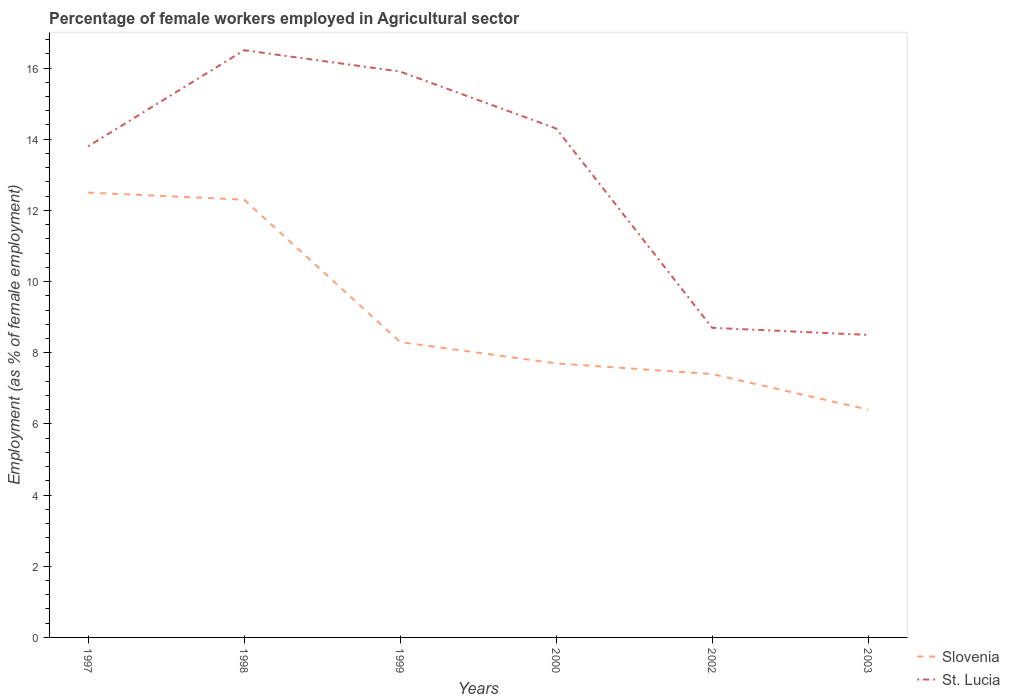How many different coloured lines are there?
Offer a very short reply. 2. Is the number of lines equal to the number of legend labels?
Give a very brief answer. Yes. Across all years, what is the maximum percentage of females employed in Agricultural sector in Slovenia?
Make the answer very short. 6.4. What is the total percentage of females employed in Agricultural sector in St. Lucia in the graph?
Your answer should be very brief. 5.8. What is the difference between the highest and the second highest percentage of females employed in Agricultural sector in Slovenia?
Give a very brief answer. 6.1. What is the difference between the highest and the lowest percentage of females employed in Agricultural sector in St. Lucia?
Make the answer very short. 4. How many lines are there?
Offer a very short reply. 2. What is the difference between two consecutive major ticks on the Y-axis?
Give a very brief answer. 2. Are the values on the major ticks of Y-axis written in scientific E-notation?
Keep it short and to the point. No. How many legend labels are there?
Keep it short and to the point. 2. What is the title of the graph?
Your answer should be compact. Percentage of female workers employed in Agricultural sector. What is the label or title of the Y-axis?
Offer a very short reply. Employment (as % of female employment). What is the Employment (as % of female employment) of St. Lucia in 1997?
Provide a succinct answer. 13.8. What is the Employment (as % of female employment) of Slovenia in 1998?
Offer a very short reply. 12.3. What is the Employment (as % of female employment) of Slovenia in 1999?
Offer a very short reply. 8.3. What is the Employment (as % of female employment) of St. Lucia in 1999?
Your response must be concise. 15.9. What is the Employment (as % of female employment) of Slovenia in 2000?
Your response must be concise. 7.7. What is the Employment (as % of female employment) in St. Lucia in 2000?
Your answer should be compact. 14.3. What is the Employment (as % of female employment) of Slovenia in 2002?
Offer a very short reply. 7.4. What is the Employment (as % of female employment) in St. Lucia in 2002?
Keep it short and to the point. 8.7. What is the Employment (as % of female employment) of Slovenia in 2003?
Your answer should be compact. 6.4. Across all years, what is the maximum Employment (as % of female employment) of Slovenia?
Your response must be concise. 12.5. Across all years, what is the maximum Employment (as % of female employment) in St. Lucia?
Offer a terse response. 16.5. Across all years, what is the minimum Employment (as % of female employment) of Slovenia?
Provide a succinct answer. 6.4. Across all years, what is the minimum Employment (as % of female employment) in St. Lucia?
Provide a short and direct response. 8.5. What is the total Employment (as % of female employment) in Slovenia in the graph?
Your answer should be very brief. 54.6. What is the total Employment (as % of female employment) of St. Lucia in the graph?
Offer a very short reply. 77.7. What is the difference between the Employment (as % of female employment) in Slovenia in 1997 and that in 1998?
Ensure brevity in your answer.  0.2. What is the difference between the Employment (as % of female employment) in St. Lucia in 1997 and that in 1999?
Your response must be concise. -2.1. What is the difference between the Employment (as % of female employment) of Slovenia in 1997 and that in 2000?
Make the answer very short. 4.8. What is the difference between the Employment (as % of female employment) in St. Lucia in 1997 and that in 2000?
Provide a succinct answer. -0.5. What is the difference between the Employment (as % of female employment) of Slovenia in 1997 and that in 2002?
Offer a very short reply. 5.1. What is the difference between the Employment (as % of female employment) in St. Lucia in 1997 and that in 2002?
Provide a succinct answer. 5.1. What is the difference between the Employment (as % of female employment) of St. Lucia in 1997 and that in 2003?
Your answer should be compact. 5.3. What is the difference between the Employment (as % of female employment) of Slovenia in 1998 and that in 2003?
Keep it short and to the point. 5.9. What is the difference between the Employment (as % of female employment) in Slovenia in 1999 and that in 2000?
Offer a very short reply. 0.6. What is the difference between the Employment (as % of female employment) in Slovenia in 1999 and that in 2002?
Provide a short and direct response. 0.9. What is the difference between the Employment (as % of female employment) in Slovenia in 2000 and that in 2002?
Offer a terse response. 0.3. What is the difference between the Employment (as % of female employment) in St. Lucia in 2000 and that in 2002?
Your answer should be very brief. 5.6. What is the difference between the Employment (as % of female employment) of Slovenia in 2000 and that in 2003?
Make the answer very short. 1.3. What is the difference between the Employment (as % of female employment) in St. Lucia in 2000 and that in 2003?
Offer a terse response. 5.8. What is the difference between the Employment (as % of female employment) in Slovenia in 1997 and the Employment (as % of female employment) in St. Lucia in 1998?
Give a very brief answer. -4. What is the difference between the Employment (as % of female employment) of Slovenia in 1997 and the Employment (as % of female employment) of St. Lucia in 1999?
Give a very brief answer. -3.4. What is the difference between the Employment (as % of female employment) in Slovenia in 1997 and the Employment (as % of female employment) in St. Lucia in 2000?
Offer a very short reply. -1.8. What is the difference between the Employment (as % of female employment) in Slovenia in 1997 and the Employment (as % of female employment) in St. Lucia in 2002?
Keep it short and to the point. 3.8. What is the difference between the Employment (as % of female employment) of Slovenia in 1998 and the Employment (as % of female employment) of St. Lucia in 2000?
Your response must be concise. -2. What is the difference between the Employment (as % of female employment) in Slovenia in 1998 and the Employment (as % of female employment) in St. Lucia in 2002?
Offer a terse response. 3.6. What is the difference between the Employment (as % of female employment) of Slovenia in 1998 and the Employment (as % of female employment) of St. Lucia in 2003?
Your answer should be very brief. 3.8. What is the difference between the Employment (as % of female employment) in Slovenia in 1999 and the Employment (as % of female employment) in St. Lucia in 2000?
Your response must be concise. -6. What is the difference between the Employment (as % of female employment) in Slovenia in 1999 and the Employment (as % of female employment) in St. Lucia in 2002?
Ensure brevity in your answer.  -0.4. What is the difference between the Employment (as % of female employment) in Slovenia in 2000 and the Employment (as % of female employment) in St. Lucia in 2003?
Provide a succinct answer. -0.8. What is the average Employment (as % of female employment) of Slovenia per year?
Offer a very short reply. 9.1. What is the average Employment (as % of female employment) of St. Lucia per year?
Your answer should be very brief. 12.95. In the year 1997, what is the difference between the Employment (as % of female employment) in Slovenia and Employment (as % of female employment) in St. Lucia?
Your answer should be compact. -1.3. In the year 1998, what is the difference between the Employment (as % of female employment) in Slovenia and Employment (as % of female employment) in St. Lucia?
Your answer should be compact. -4.2. In the year 2000, what is the difference between the Employment (as % of female employment) of Slovenia and Employment (as % of female employment) of St. Lucia?
Your answer should be compact. -6.6. In the year 2002, what is the difference between the Employment (as % of female employment) of Slovenia and Employment (as % of female employment) of St. Lucia?
Your answer should be compact. -1.3. What is the ratio of the Employment (as % of female employment) in Slovenia in 1997 to that in 1998?
Ensure brevity in your answer.  1.02. What is the ratio of the Employment (as % of female employment) of St. Lucia in 1997 to that in 1998?
Ensure brevity in your answer.  0.84. What is the ratio of the Employment (as % of female employment) of Slovenia in 1997 to that in 1999?
Your response must be concise. 1.51. What is the ratio of the Employment (as % of female employment) of St. Lucia in 1997 to that in 1999?
Make the answer very short. 0.87. What is the ratio of the Employment (as % of female employment) of Slovenia in 1997 to that in 2000?
Ensure brevity in your answer.  1.62. What is the ratio of the Employment (as % of female employment) in St. Lucia in 1997 to that in 2000?
Offer a terse response. 0.96. What is the ratio of the Employment (as % of female employment) in Slovenia in 1997 to that in 2002?
Your answer should be very brief. 1.69. What is the ratio of the Employment (as % of female employment) in St. Lucia in 1997 to that in 2002?
Ensure brevity in your answer.  1.59. What is the ratio of the Employment (as % of female employment) in Slovenia in 1997 to that in 2003?
Your answer should be compact. 1.95. What is the ratio of the Employment (as % of female employment) of St. Lucia in 1997 to that in 2003?
Ensure brevity in your answer.  1.62. What is the ratio of the Employment (as % of female employment) in Slovenia in 1998 to that in 1999?
Provide a succinct answer. 1.48. What is the ratio of the Employment (as % of female employment) of St. Lucia in 1998 to that in 1999?
Make the answer very short. 1.04. What is the ratio of the Employment (as % of female employment) in Slovenia in 1998 to that in 2000?
Give a very brief answer. 1.6. What is the ratio of the Employment (as % of female employment) of St. Lucia in 1998 to that in 2000?
Give a very brief answer. 1.15. What is the ratio of the Employment (as % of female employment) of Slovenia in 1998 to that in 2002?
Provide a short and direct response. 1.66. What is the ratio of the Employment (as % of female employment) of St. Lucia in 1998 to that in 2002?
Provide a succinct answer. 1.9. What is the ratio of the Employment (as % of female employment) in Slovenia in 1998 to that in 2003?
Give a very brief answer. 1.92. What is the ratio of the Employment (as % of female employment) in St. Lucia in 1998 to that in 2003?
Your answer should be compact. 1.94. What is the ratio of the Employment (as % of female employment) in Slovenia in 1999 to that in 2000?
Offer a very short reply. 1.08. What is the ratio of the Employment (as % of female employment) of St. Lucia in 1999 to that in 2000?
Your response must be concise. 1.11. What is the ratio of the Employment (as % of female employment) in Slovenia in 1999 to that in 2002?
Ensure brevity in your answer.  1.12. What is the ratio of the Employment (as % of female employment) in St. Lucia in 1999 to that in 2002?
Your response must be concise. 1.83. What is the ratio of the Employment (as % of female employment) of Slovenia in 1999 to that in 2003?
Your answer should be very brief. 1.3. What is the ratio of the Employment (as % of female employment) of St. Lucia in 1999 to that in 2003?
Ensure brevity in your answer.  1.87. What is the ratio of the Employment (as % of female employment) in Slovenia in 2000 to that in 2002?
Provide a short and direct response. 1.04. What is the ratio of the Employment (as % of female employment) of St. Lucia in 2000 to that in 2002?
Your answer should be compact. 1.64. What is the ratio of the Employment (as % of female employment) in Slovenia in 2000 to that in 2003?
Your answer should be very brief. 1.2. What is the ratio of the Employment (as % of female employment) in St. Lucia in 2000 to that in 2003?
Offer a very short reply. 1.68. What is the ratio of the Employment (as % of female employment) of Slovenia in 2002 to that in 2003?
Your answer should be very brief. 1.16. What is the ratio of the Employment (as % of female employment) of St. Lucia in 2002 to that in 2003?
Keep it short and to the point. 1.02. What is the difference between the highest and the second highest Employment (as % of female employment) of Slovenia?
Your response must be concise. 0.2. What is the difference between the highest and the second highest Employment (as % of female employment) of St. Lucia?
Offer a very short reply. 0.6. What is the difference between the highest and the lowest Employment (as % of female employment) in St. Lucia?
Your answer should be very brief. 8. 